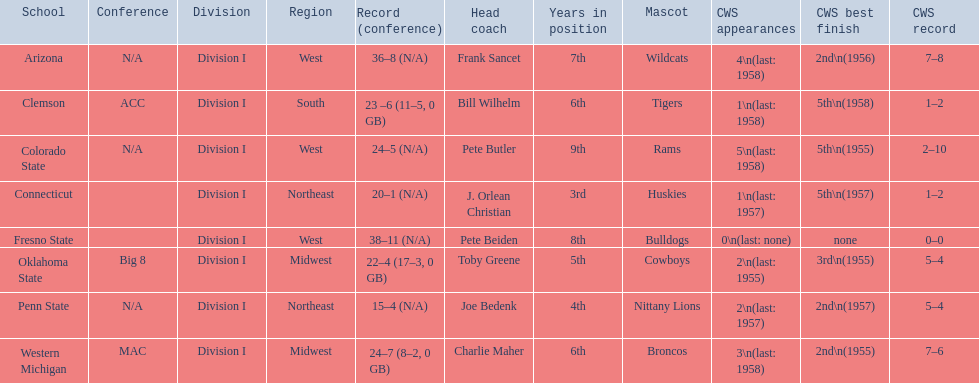What were scores for each school in the 1959 ncaa tournament? 36–8 (N/A), 23 –6 (11–5, 0 GB), 24–5 (N/A), 20–1 (N/A), 38–11 (N/A), 22–4 (17–3, 0 GB), 15–4 (N/A), 24–7 (8–2, 0 GB). What score did not have at least 16 wins? 15–4 (N/A). Can you parse all the data within this table? {'header': ['School', 'Conference', 'Division', 'Region', 'Record (conference)', 'Head coach', 'Years in position', 'Mascot', 'CWS appearances', 'CWS best finish', 'CWS record'], 'rows': [['Arizona', 'N/A', 'Division I', 'West', '36–8 (N/A)', 'Frank Sancet', '7th', 'Wildcats', '4\\n(last: 1958)', '2nd\\n(1956)', '7–8'], ['Clemson', 'ACC', 'Division I', 'South', '23 –6 (11–5, 0 GB)', 'Bill Wilhelm', '6th', 'Tigers', '1\\n(last: 1958)', '5th\\n(1958)', '1–2'], ['Colorado State', 'N/A', 'Division I', 'West', '24–5 (N/A)', 'Pete Butler', '9th', 'Rams', '5\\n(last: 1958)', '5th\\n(1955)', '2–10'], ['Connecticut', '', 'Division I', 'Northeast', '20–1 (N/A)', 'J. Orlean Christian', '3rd', 'Huskies', '1\\n(last: 1957)', '5th\\n(1957)', '1–2'], ['Fresno State', '', 'Division I', 'West', '38–11 (N/A)', 'Pete Beiden', '8th', 'Bulldogs', '0\\n(last: none)', 'none', '0–0'], ['Oklahoma State', 'Big 8', 'Division I', 'Midwest', '22–4 (17–3, 0 GB)', 'Toby Greene', '5th', 'Cowboys', '2\\n(last: 1955)', '3rd\\n(1955)', '5–4'], ['Penn State', 'N/A', 'Division I', 'Northeast', '15–4 (N/A)', 'Joe Bedenk', '4th', 'Nittany Lions', '2\\n(last: 1957)', '2nd\\n(1957)', '5–4'], ['Western Michigan', 'MAC', 'Division I', 'Midwest', '24–7 (8–2, 0 GB)', 'Charlie Maher', '6th', 'Broncos', '3\\n(last: 1958)', '2nd\\n(1955)', '7–6']]} What team earned this score? Penn State. 